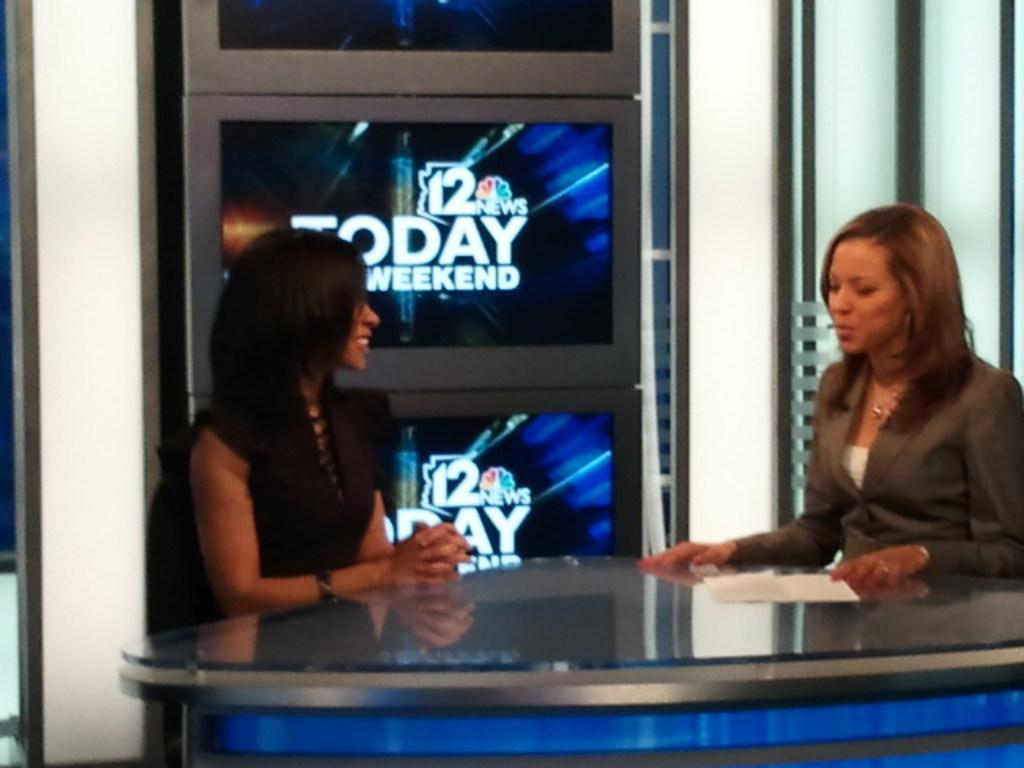Provide a one-sentence caption for the provided image. Two female anchors engaged in a conversation on a TV set for 12 News Today Weekend edition. 